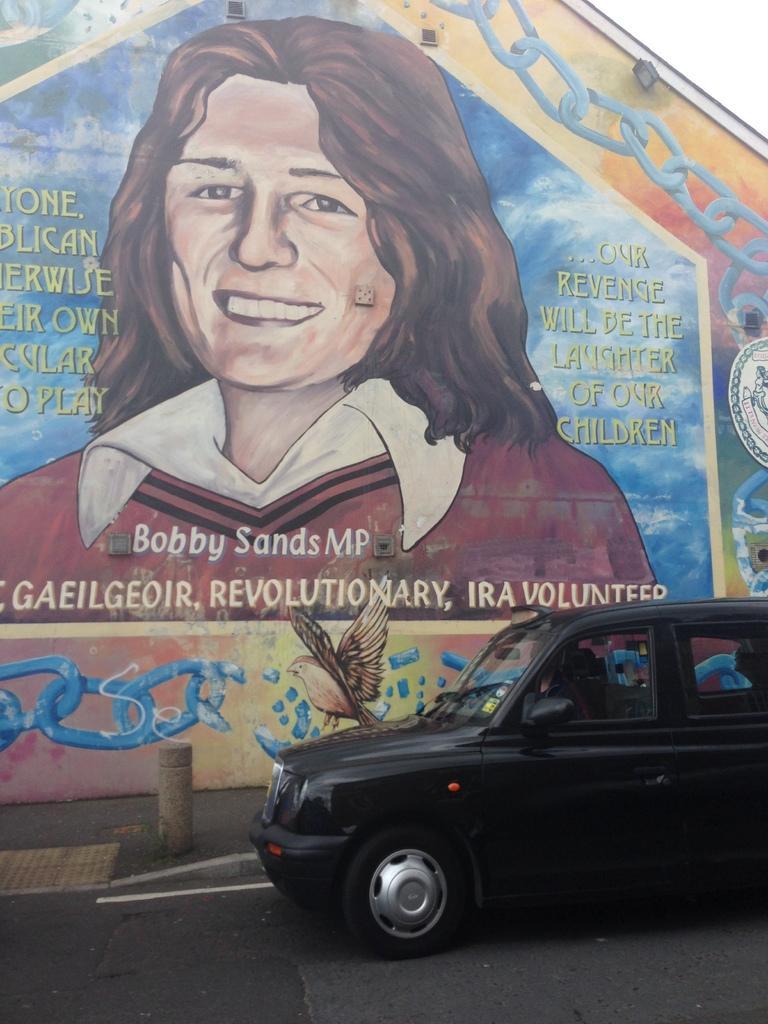Could you give a brief overview of what you see in this image? In this image there is a road, on that road there is a car, in the background there is a wall for that wall, there is painting of a woman and some text is written on that. 